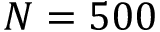Convert formula to latex. <formula><loc_0><loc_0><loc_500><loc_500>N = 5 0 0</formula> 